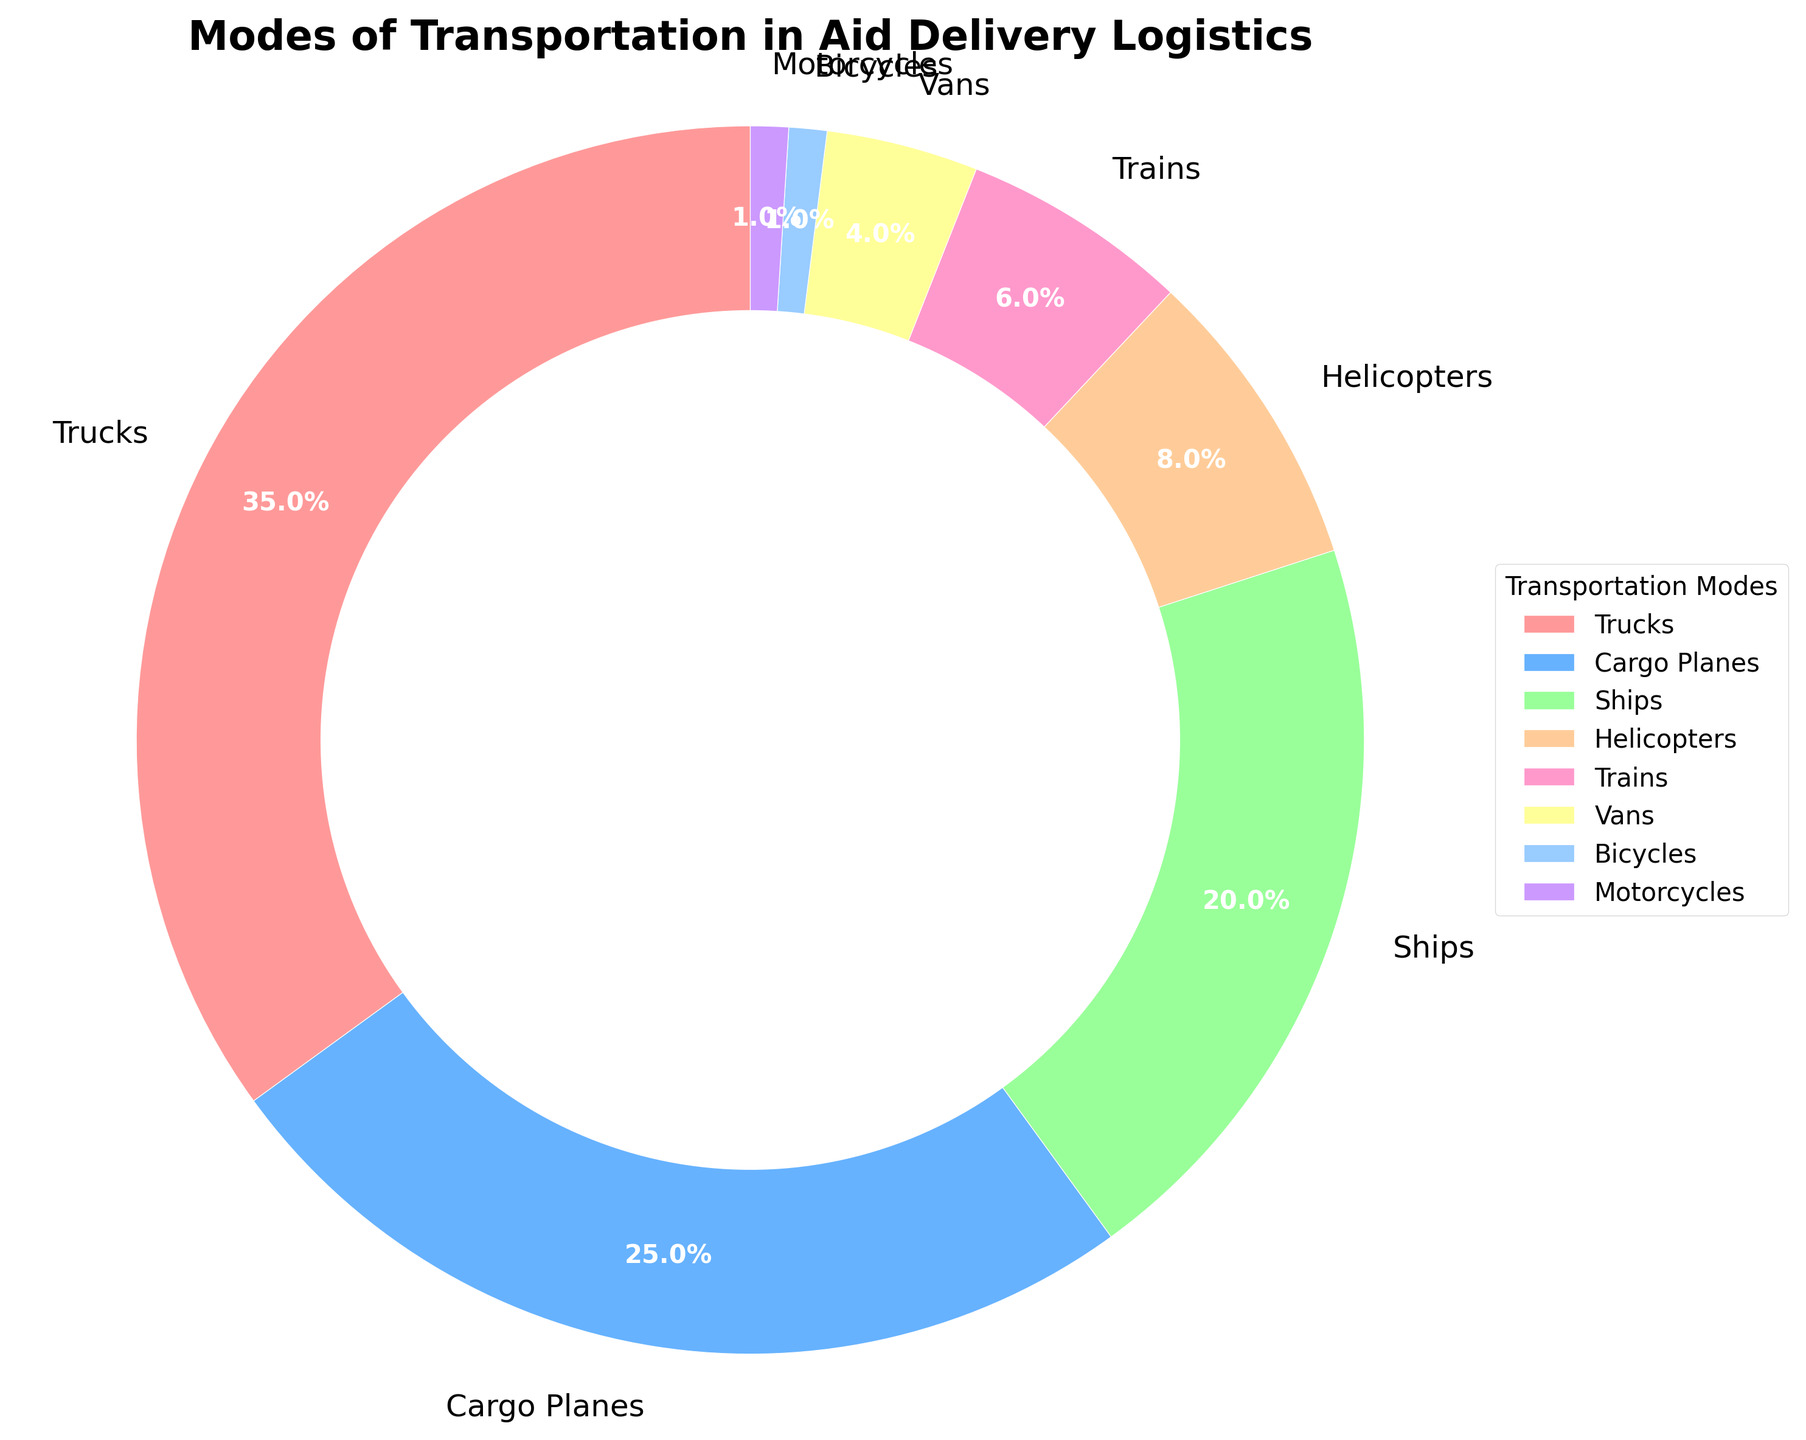Which mode of transportation is most frequently used for aid delivery? By looking at the largest segment in the pie chart, we see that the section corresponding to trucks is the largest. This indicates that trucks are the most frequently used mode of transportation for aid delivery.
Answer: Trucks Which two modes of transportation combined account for more than half of the total transportation? We need to find the two largest segments and sum their percentages. Trucks account for 35% and cargo planes account for 25%. Summing 35% and 25%, we get 60%, which is more than half.
Answer: Trucks and Cargo Planes How much more frequently are trucks used compared to helicopters? To find the difference, subtract the percentage of helicopters from the percentage of trucks: 35% (trucks) - 8% (helicopters) = 27%.
Answer: 27% Which mode of transportation is the least used? By identifying the smallest segment in the pie chart, we see that bicycles and motorcycles both account for the smallest size, which is 1% each.
Answer: Bicycles and Motorcycles What is the combined percentage of aid delivered by ships, trains, vans, helicopters, bicycles, and motorcycles? We add the percentages of all these modes together: 20% (ships) + 6% (trains) + 4% (vans) + 8% (helicopters) + 1% (bicycles) + 1% (motorcycles) = 40%.
Answer: 40% Which mode of transportation is represented by the second-largest segment in the pie chart? By examining the segments, the second-largest segment corresponds to cargo planes.
Answer: Cargo Planes By how much does the usage of trucks exceed the combined use of trains and vans? First, sum the percentages for trains and vans: 6% (trains) + 4% (vans) = 10%. Then, subtract this sum from the percentage of trucks: 35% (trucks) - 10% = 25%.
Answer: 25% How many modes of transportation are used less frequently than helicopters? Identifying the segments smaller than helicopters (8%) includes trains (6%), vans (4%), bicycles (1%), and motorcycles (1%). There are 4 such modes.
Answer: 4 Compare the use of cargo planes to ships. Which is used more and by what percentage? Cargo planes are used more frequently than ships. Comparing their percentages: 25% (cargo planes) - 20% (ships) = 5%.
Answer: Cargo planes by 5% 